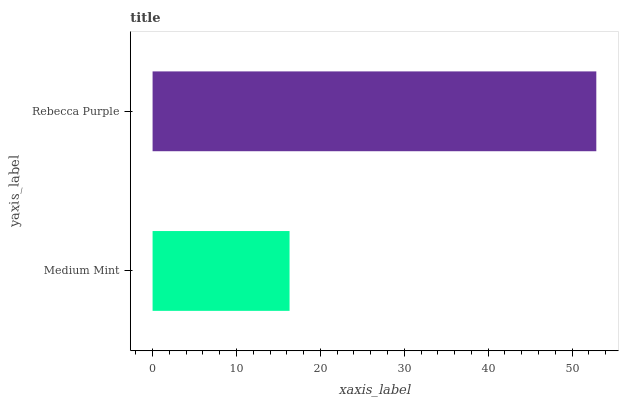Is Medium Mint the minimum?
Answer yes or no. Yes. Is Rebecca Purple the maximum?
Answer yes or no. Yes. Is Rebecca Purple the minimum?
Answer yes or no. No. Is Rebecca Purple greater than Medium Mint?
Answer yes or no. Yes. Is Medium Mint less than Rebecca Purple?
Answer yes or no. Yes. Is Medium Mint greater than Rebecca Purple?
Answer yes or no. No. Is Rebecca Purple less than Medium Mint?
Answer yes or no. No. Is Rebecca Purple the high median?
Answer yes or no. Yes. Is Medium Mint the low median?
Answer yes or no. Yes. Is Medium Mint the high median?
Answer yes or no. No. Is Rebecca Purple the low median?
Answer yes or no. No. 